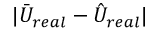<formula> <loc_0><loc_0><loc_500><loc_500>| \bar { U } _ { r e a l } - \hat { U } _ { r e a l } |</formula> 